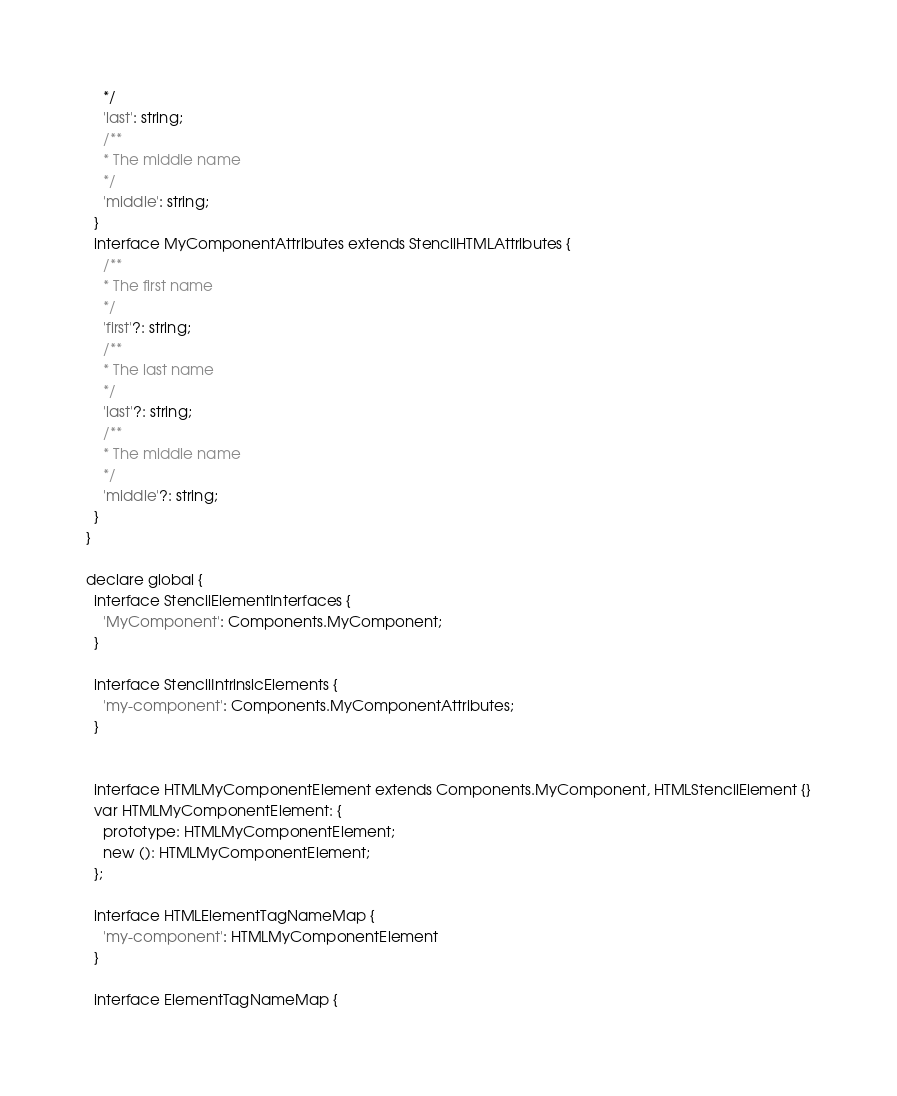Convert code to text. <code><loc_0><loc_0><loc_500><loc_500><_TypeScript_>    */
    'last': string;
    /**
    * The middle name
    */
    'middle': string;
  }
  interface MyComponentAttributes extends StencilHTMLAttributes {
    /**
    * The first name
    */
    'first'?: string;
    /**
    * The last name
    */
    'last'?: string;
    /**
    * The middle name
    */
    'middle'?: string;
  }
}

declare global {
  interface StencilElementInterfaces {
    'MyComponent': Components.MyComponent;
  }

  interface StencilIntrinsicElements {
    'my-component': Components.MyComponentAttributes;
  }


  interface HTMLMyComponentElement extends Components.MyComponent, HTMLStencilElement {}
  var HTMLMyComponentElement: {
    prototype: HTMLMyComponentElement;
    new (): HTMLMyComponentElement;
  };

  interface HTMLElementTagNameMap {
    'my-component': HTMLMyComponentElement
  }

  interface ElementTagNameMap {</code> 